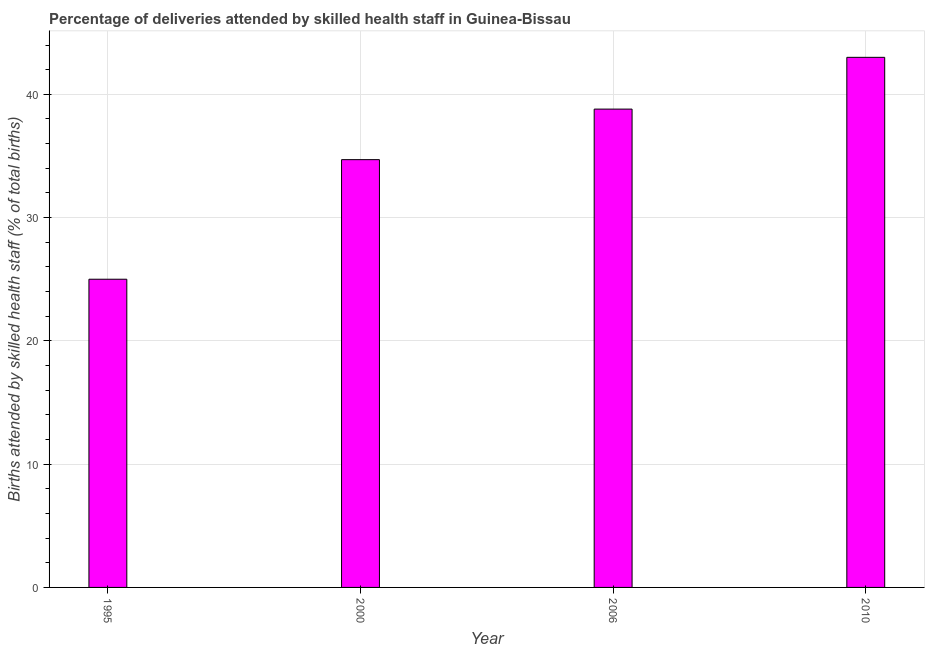Does the graph contain grids?
Your answer should be very brief. Yes. What is the title of the graph?
Make the answer very short. Percentage of deliveries attended by skilled health staff in Guinea-Bissau. What is the label or title of the Y-axis?
Give a very brief answer. Births attended by skilled health staff (% of total births). Across all years, what is the minimum number of births attended by skilled health staff?
Your response must be concise. 25. In which year was the number of births attended by skilled health staff maximum?
Keep it short and to the point. 2010. What is the sum of the number of births attended by skilled health staff?
Offer a terse response. 141.5. What is the difference between the number of births attended by skilled health staff in 1995 and 2010?
Make the answer very short. -18. What is the average number of births attended by skilled health staff per year?
Your answer should be very brief. 35.38. What is the median number of births attended by skilled health staff?
Provide a short and direct response. 36.75. Do a majority of the years between 2006 and 1995 (inclusive) have number of births attended by skilled health staff greater than 24 %?
Offer a terse response. Yes. What is the ratio of the number of births attended by skilled health staff in 2000 to that in 2010?
Your answer should be very brief. 0.81. Is the number of births attended by skilled health staff in 1995 less than that in 2006?
Ensure brevity in your answer.  Yes. Are all the bars in the graph horizontal?
Offer a terse response. No. What is the difference between two consecutive major ticks on the Y-axis?
Ensure brevity in your answer.  10. Are the values on the major ticks of Y-axis written in scientific E-notation?
Give a very brief answer. No. What is the Births attended by skilled health staff (% of total births) in 2000?
Your answer should be compact. 34.7. What is the Births attended by skilled health staff (% of total births) of 2006?
Offer a very short reply. 38.8. What is the difference between the Births attended by skilled health staff (% of total births) in 1995 and 2006?
Offer a terse response. -13.8. What is the difference between the Births attended by skilled health staff (% of total births) in 2000 and 2006?
Provide a succinct answer. -4.1. What is the difference between the Births attended by skilled health staff (% of total births) in 2000 and 2010?
Your response must be concise. -8.3. What is the difference between the Births attended by skilled health staff (% of total births) in 2006 and 2010?
Your answer should be very brief. -4.2. What is the ratio of the Births attended by skilled health staff (% of total births) in 1995 to that in 2000?
Offer a very short reply. 0.72. What is the ratio of the Births attended by skilled health staff (% of total births) in 1995 to that in 2006?
Provide a short and direct response. 0.64. What is the ratio of the Births attended by skilled health staff (% of total births) in 1995 to that in 2010?
Ensure brevity in your answer.  0.58. What is the ratio of the Births attended by skilled health staff (% of total births) in 2000 to that in 2006?
Offer a terse response. 0.89. What is the ratio of the Births attended by skilled health staff (% of total births) in 2000 to that in 2010?
Keep it short and to the point. 0.81. What is the ratio of the Births attended by skilled health staff (% of total births) in 2006 to that in 2010?
Your answer should be compact. 0.9. 